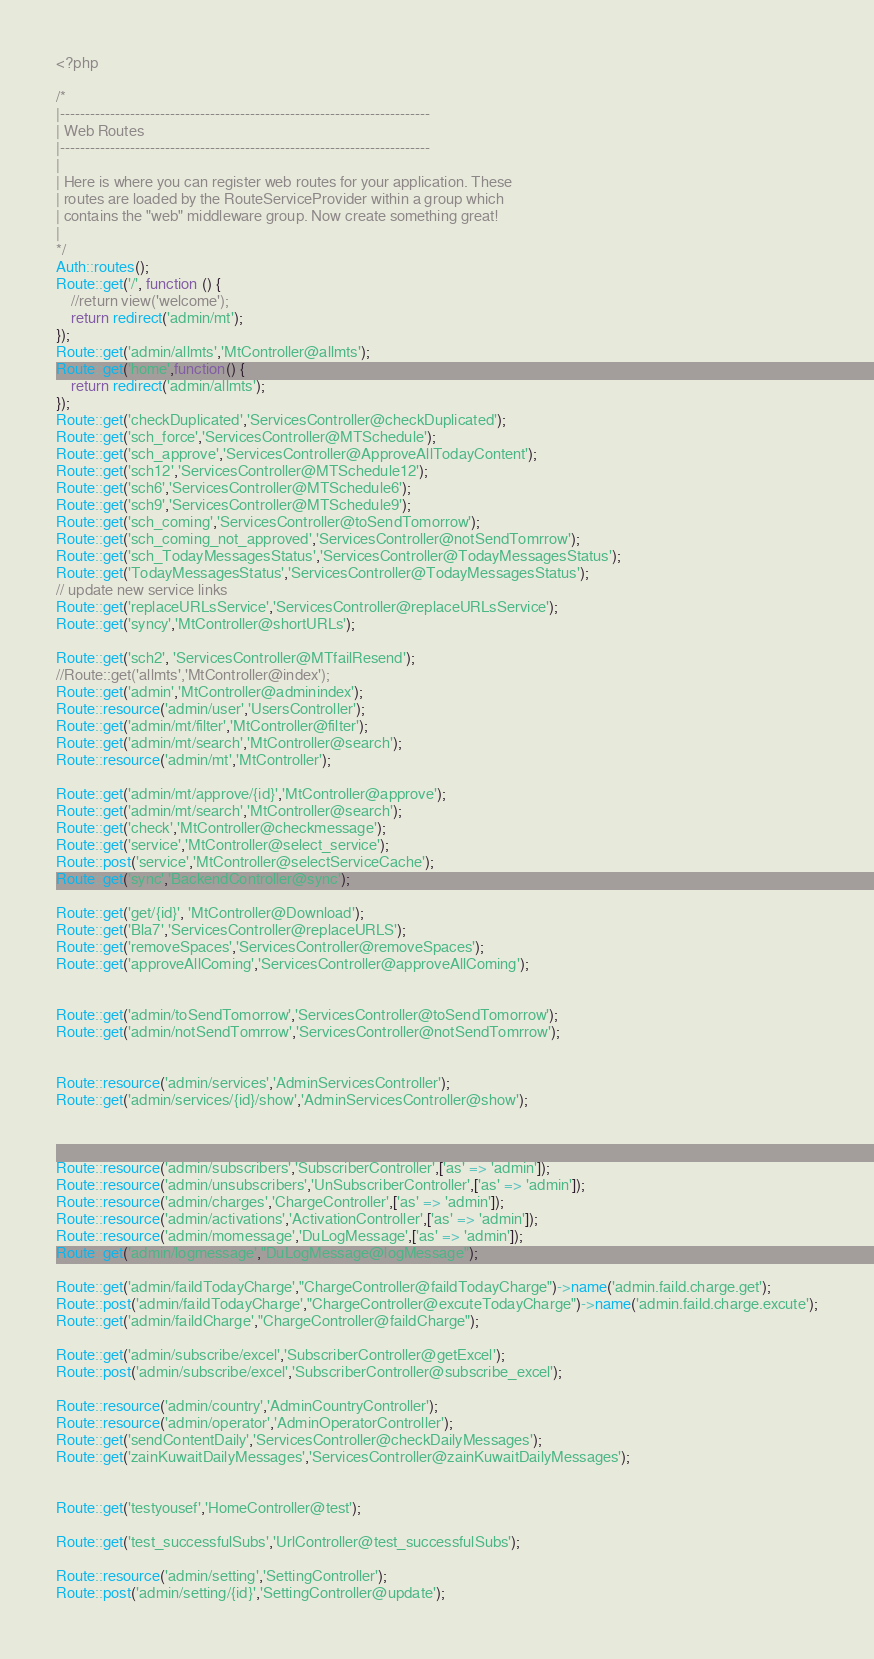<code> <loc_0><loc_0><loc_500><loc_500><_PHP_><?php

/*
|--------------------------------------------------------------------------
| Web Routes
|--------------------------------------------------------------------------
|
| Here is where you can register web routes for your application. These
| routes are loaded by the RouteServiceProvider within a group which
| contains the "web" middleware group. Now create something great!
|
*/
Auth::routes();
Route::get('/', function () {
    //return view('welcome');
    return redirect('admin/mt');
});
Route::get('admin/allmts','MtController@allmts');
Route::get('home',function() {
    return redirect('admin/allmts');
});
Route::get('checkDuplicated','ServicesController@checkDuplicated');
Route::get('sch_force','ServicesController@MTSchedule');
Route::get('sch_approve','ServicesController@ApproveAllTodayContent');
Route::get('sch12','ServicesController@MTSchedule12');
Route::get('sch6','ServicesController@MTSchedule6');
Route::get('sch9','ServicesController@MTSchedule9');
Route::get('sch_coming','ServicesController@toSendTomorrow');
Route::get('sch_coming_not_approved','ServicesController@notSendTomrrow');
Route::get('sch_TodayMessagesStatus','ServicesController@TodayMessagesStatus');
Route::get('TodayMessagesStatus','ServicesController@TodayMessagesStatus');
// update new service links
Route::get('replaceURLsService','ServicesController@replaceURLsService');
Route::get('syncy','MtController@shortURLs');

Route::get('sch2', 'ServicesController@MTfailResend');
//Route::get('allmts','MtController@index');
Route::get('admin','MtController@adminindex');
Route::resource('admin/user','UsersController');
Route::get('admin/mt/filter','MtController@filter');
Route::get('admin/mt/search','MtController@search');
Route::resource('admin/mt','MtController');

Route::get('admin/mt/approve/{id}','MtController@approve');
Route::get('admin/mt/search','MtController@search');
Route::get('check','MtController@checkmessage');
Route::get('service','MtController@select_service');
Route::post('service','MtController@selectServiceCache');
Route::get('sync','BackendController@sync');

Route::get('get/{id}', 'MtController@Download');
Route::get('Bla7','ServicesController@replaceURLS');
Route::get('removeSpaces','ServicesController@removeSpaces');
Route::get('approveAllComing','ServicesController@approveAllComing');


Route::get('admin/toSendTomorrow','ServicesController@toSendTomorrow');
Route::get('admin/notSendTomrrow','ServicesController@notSendTomrrow');


Route::resource('admin/services','AdminServicesController');
Route::get('admin/services/{id}/show','AdminServicesController@show');



Route::resource('admin/subscribers','SubscriberController',['as' => 'admin']);
Route::resource('admin/unsubscribers','UnSubscriberController',['as' => 'admin']);
Route::resource('admin/charges','ChargeController',['as' => 'admin']);
Route::resource('admin/activations','ActivationController',['as' => 'admin']);
Route::resource('admin/momessage','DuLogMessage',['as' => 'admin']);
Route::get('admin/logmessage',"DuLogMessage@logMessage");

Route::get('admin/faildTodayCharge',"ChargeController@faildTodayCharge")->name('admin.faild.charge.get');
Route::post('admin/faildTodayCharge',"ChargeController@excuteTodayCharge")->name('admin.faild.charge.excute');
Route::get('admin/faildCharge',"ChargeController@faildCharge");

Route::get('admin/subscribe/excel','SubscriberController@getExcel');
Route::post('admin/subscribe/excel','SubscriberController@subscribe_excel');

Route::resource('admin/country','AdminCountryController');
Route::resource('admin/operator','AdminOperatorController');
Route::get('sendContentDaily','ServicesController@checkDailyMessages');
Route::get('zainKuwaitDailyMessages','ServicesController@zainKuwaitDailyMessages');


Route::get('testyousef','HomeController@test');

Route::get('test_successfulSubs','UrlController@test_successfulSubs');

Route::resource('admin/setting','SettingController');
Route::post('admin/setting/{id}','SettingController@update');

</code> 